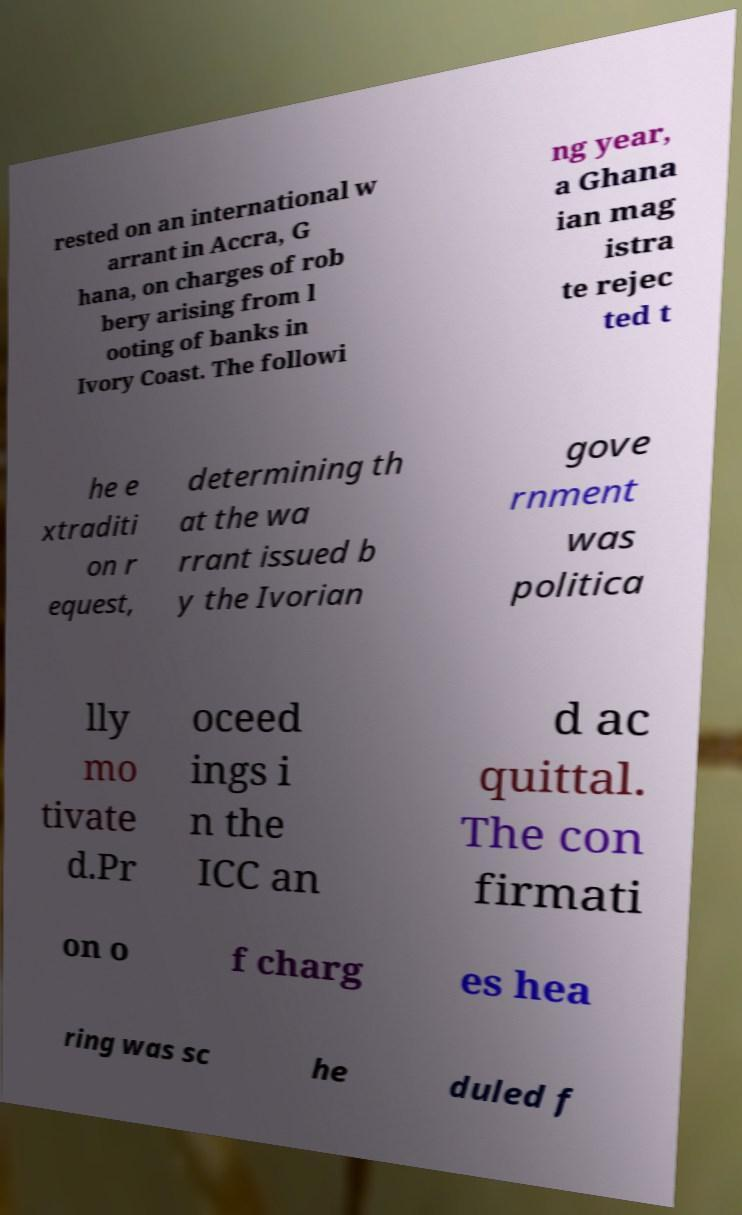There's text embedded in this image that I need extracted. Can you transcribe it verbatim? rested on an international w arrant in Accra, G hana, on charges of rob bery arising from l ooting of banks in Ivory Coast. The followi ng year, a Ghana ian mag istra te rejec ted t he e xtraditi on r equest, determining th at the wa rrant issued b y the Ivorian gove rnment was politica lly mo tivate d.Pr oceed ings i n the ICC an d ac quittal. The con firmati on o f charg es hea ring was sc he duled f 